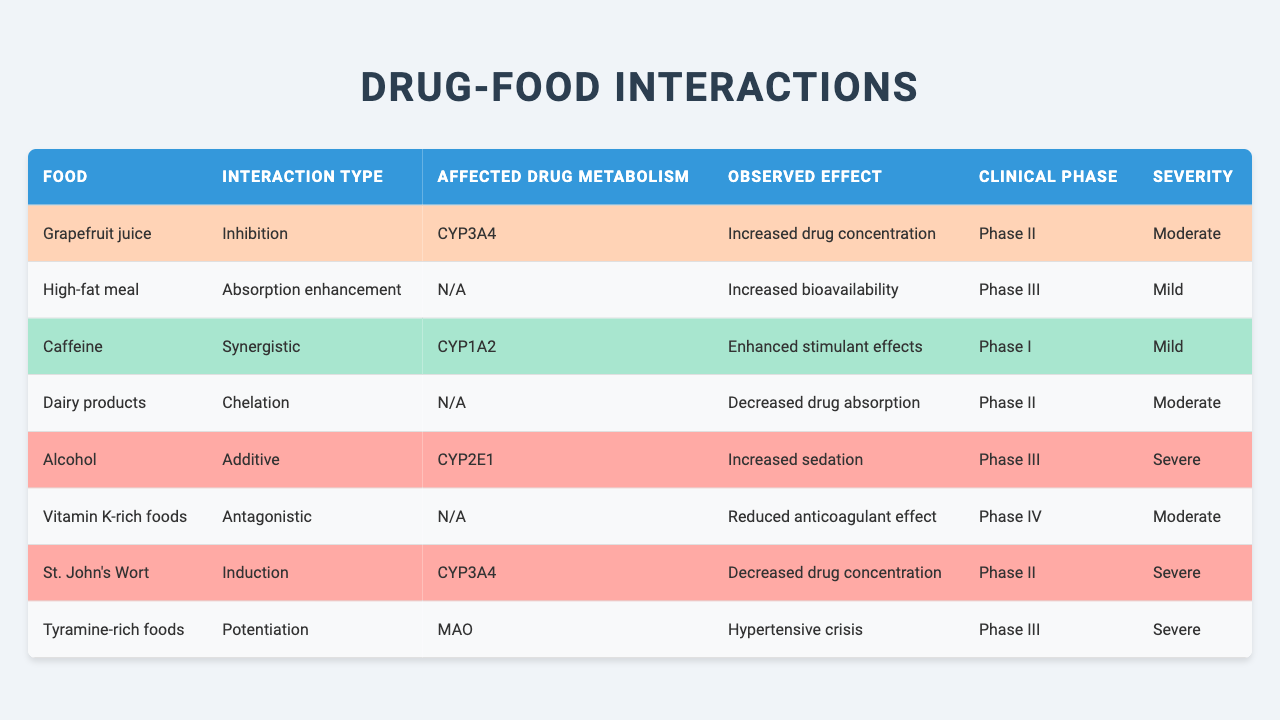What food is associated with a synergistic interaction? The table lists "Caffeine" as the food with a synergistic interaction.
Answer: Caffeine In which clinical phase was the chelation interaction with dairy products observed? According to the table, the interaction with dairy products was observed in Phase II.
Answer: Phase II How many foods have a severe severity rating? There are three foods with a severe severity rating: Alcohol, St. John's Wort, and Tyramine-rich foods.
Answer: 3 Is grapefruit juice associated with a decrease in drug concentration? The table specifies that grapefruit juice causes an increased drug concentration, not a decrease, so the answer is no.
Answer: No What is the observed effect of a high-fat meal on drug bioavailability? The high-fat meal is noted to enhance absorption, leading to increased bioavailability.
Answer: Increased bioavailability Which food interaction was noted in Phase IV of clinical testing? The interaction with Vitamin K-rich foods was noted in Phase IV, according to the table.
Answer: Vitamin K-rich foods Calculate the total number of foods listed for Phase III interactions. There are 2 foods listed for Phase III interactions: High-fat meal and Alcohol.
Answer: 2 Does dairy products cause an enhancement of drug absorption? The table indicates that dairy products cause decreased drug absorption, so the answer is no.
Answer: No Identify two foods that interact with CYP3A4. Grapefruit juice and St. John's Wort both interact with CYP3A4 according to the table.
Answer: Grapefruit juice and St. John's Wort What is the interaction type associated with alcohol? The interaction type for alcohol is classified as additive.
Answer: Additive 